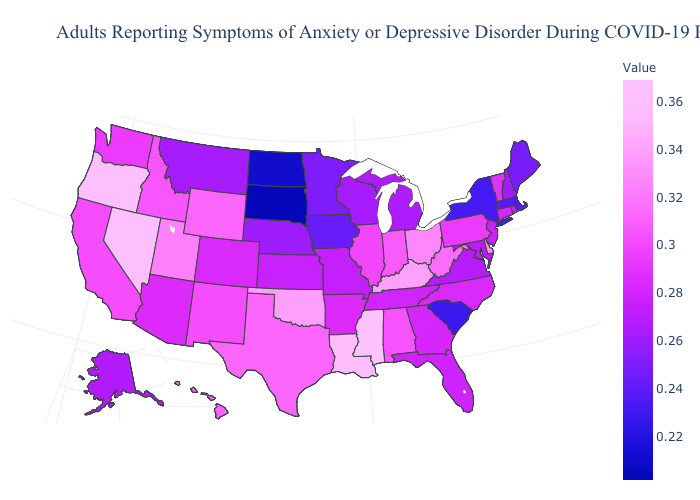Which states hav the highest value in the MidWest?
Be succinct. Ohio. Does Alabama have the lowest value in the USA?
Short answer required. No. Which states have the lowest value in the West?
Answer briefly. Montana. Among the states that border New Hampshire , which have the highest value?
Concise answer only. Vermont. Does South Dakota have the lowest value in the USA?
Be succinct. Yes. Is the legend a continuous bar?
Concise answer only. Yes. Among the states that border Colorado , which have the highest value?
Write a very short answer. Oklahoma. 